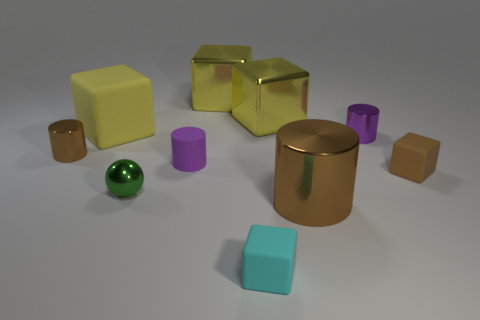Are the brown thing to the left of the big rubber cube and the brown cube made of the same material?
Ensure brevity in your answer.  No. Do the cylinder that is on the left side of the big matte object and the large brown thing that is in front of the tiny green thing have the same material?
Your answer should be compact. Yes. Is the number of big cylinders that are behind the cyan thing greater than the number of tiny yellow shiny spheres?
Ensure brevity in your answer.  Yes. The tiny shiny cylinder in front of the small shiny cylinder that is on the right side of the green thing is what color?
Provide a succinct answer. Brown. What is the shape of the brown object that is the same size as the yellow matte block?
Give a very brief answer. Cylinder. The rubber object that is the same color as the large cylinder is what shape?
Make the answer very short. Cube. Is the number of small brown rubber blocks that are behind the small rubber cylinder the same as the number of large metal cylinders?
Make the answer very short. No. What material is the brown object behind the tiny cube right of the tiny metallic cylinder that is to the right of the cyan thing?
Your answer should be very brief. Metal. The tiny green object that is the same material as the tiny brown cylinder is what shape?
Your response must be concise. Sphere. Are there any other things of the same color as the small matte cylinder?
Your answer should be very brief. Yes. 